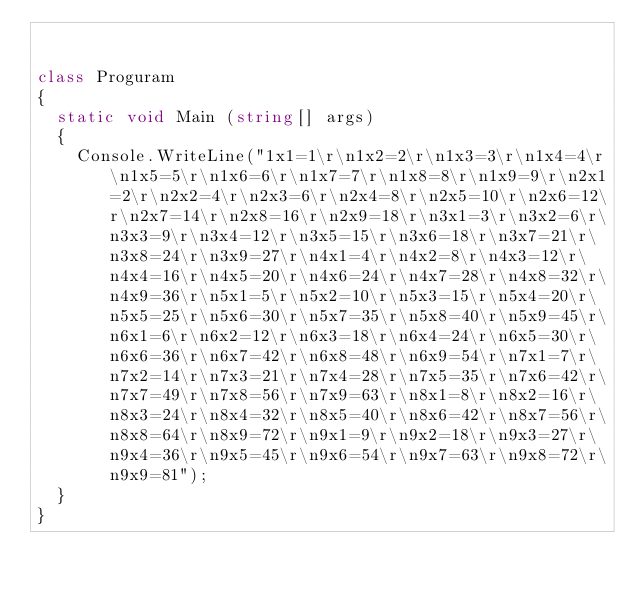<code> <loc_0><loc_0><loc_500><loc_500><_C#_>

class Proguram
{
	static void Main (string[] args)
	{
		Console.WriteLine("1x1=1\r\n1x2=2\r\n1x3=3\r\n1x4=4\r\n1x5=5\r\n1x6=6\r\n1x7=7\r\n1x8=8\r\n1x9=9\r\n2x1=2\r\n2x2=4\r\n2x3=6\r\n2x4=8\r\n2x5=10\r\n2x6=12\r\n2x7=14\r\n2x8=16\r\n2x9=18\r\n3x1=3\r\n3x2=6\r\n3x3=9\r\n3x4=12\r\n3x5=15\r\n3x6=18\r\n3x7=21\r\n3x8=24\r\n3x9=27\r\n4x1=4\r\n4x2=8\r\n4x3=12\r\n4x4=16\r\n4x5=20\r\n4x6=24\r\n4x7=28\r\n4x8=32\r\n4x9=36\r\n5x1=5\r\n5x2=10\r\n5x3=15\r\n5x4=20\r\n5x5=25\r\n5x6=30\r\n5x7=35\r\n5x8=40\r\n5x9=45\r\n6x1=6\r\n6x2=12\r\n6x3=18\r\n6x4=24\r\n6x5=30\r\n6x6=36\r\n6x7=42\r\n6x8=48\r\n6x9=54\r\n7x1=7\r\n7x2=14\r\n7x3=21\r\n7x4=28\r\n7x5=35\r\n7x6=42\r\n7x7=49\r\n7x8=56\r\n7x9=63\r\n8x1=8\r\n8x2=16\r\n8x3=24\r\n8x4=32\r\n8x5=40\r\n8x6=42\r\n8x7=56\r\n8x8=64\r\n8x9=72\r\n9x1=9\r\n9x2=18\r\n9x3=27\r\n9x4=36\r\n9x5=45\r\n9x6=54\r\n9x7=63\r\n9x8=72\r\n9x9=81");
	}
}</code> 